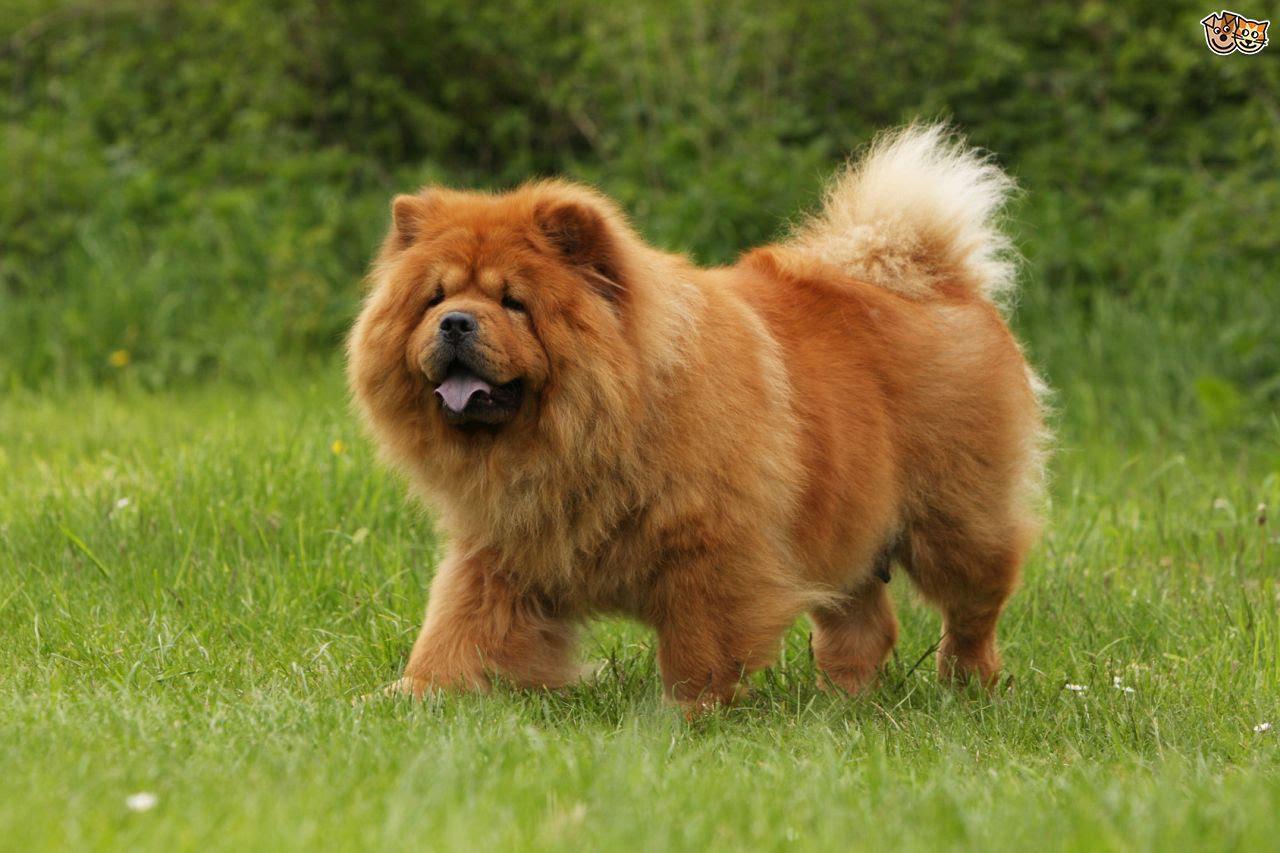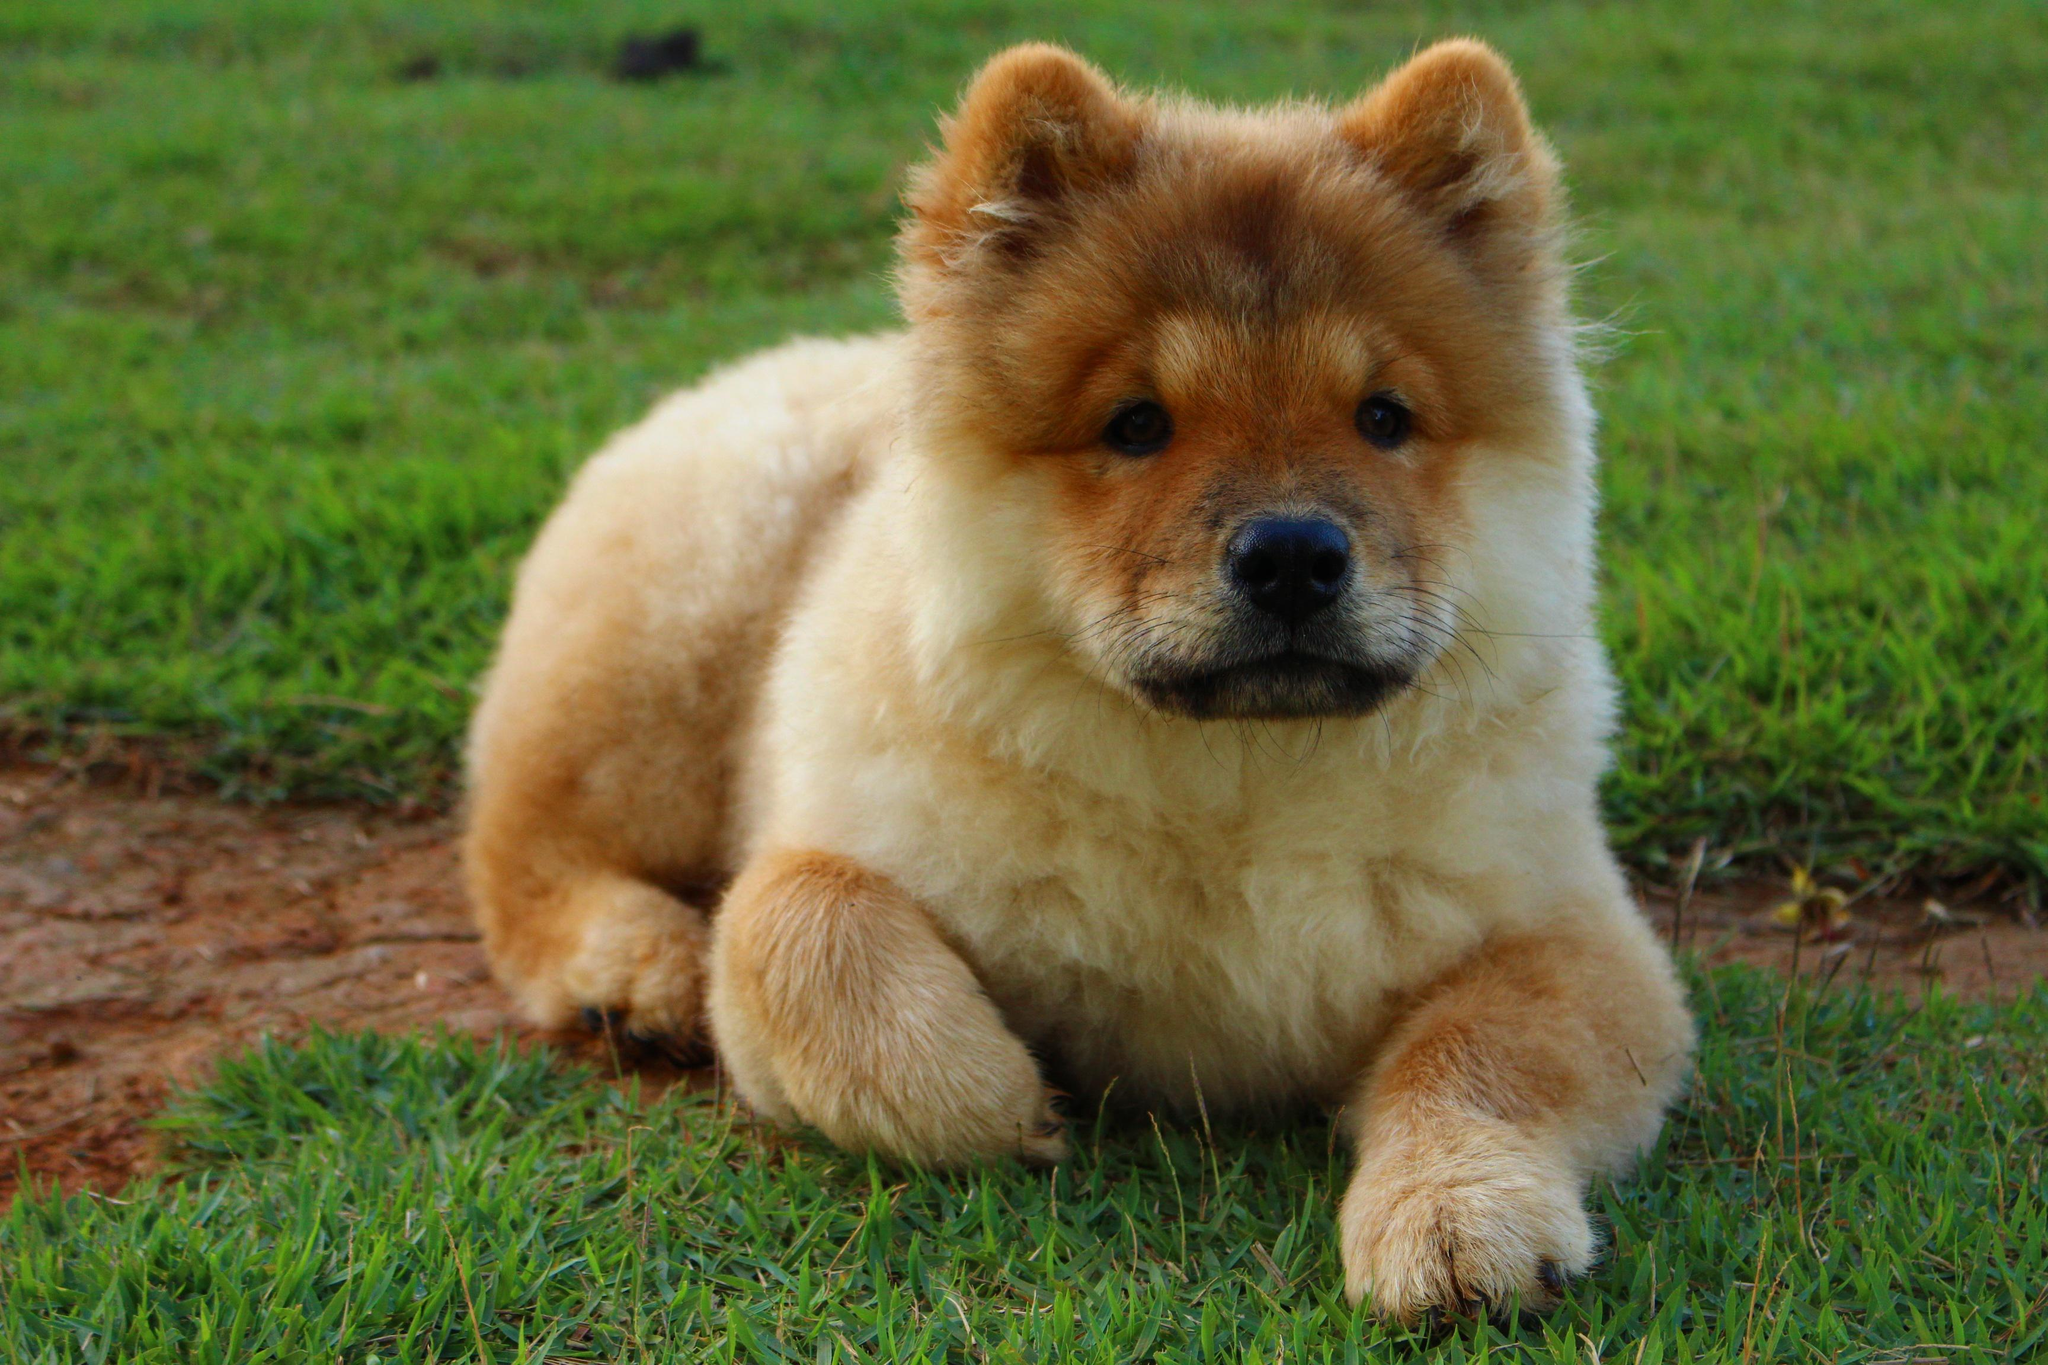The first image is the image on the left, the second image is the image on the right. Given the left and right images, does the statement "The dog in the image on the right has its mouth open" hold true? Answer yes or no. No. 